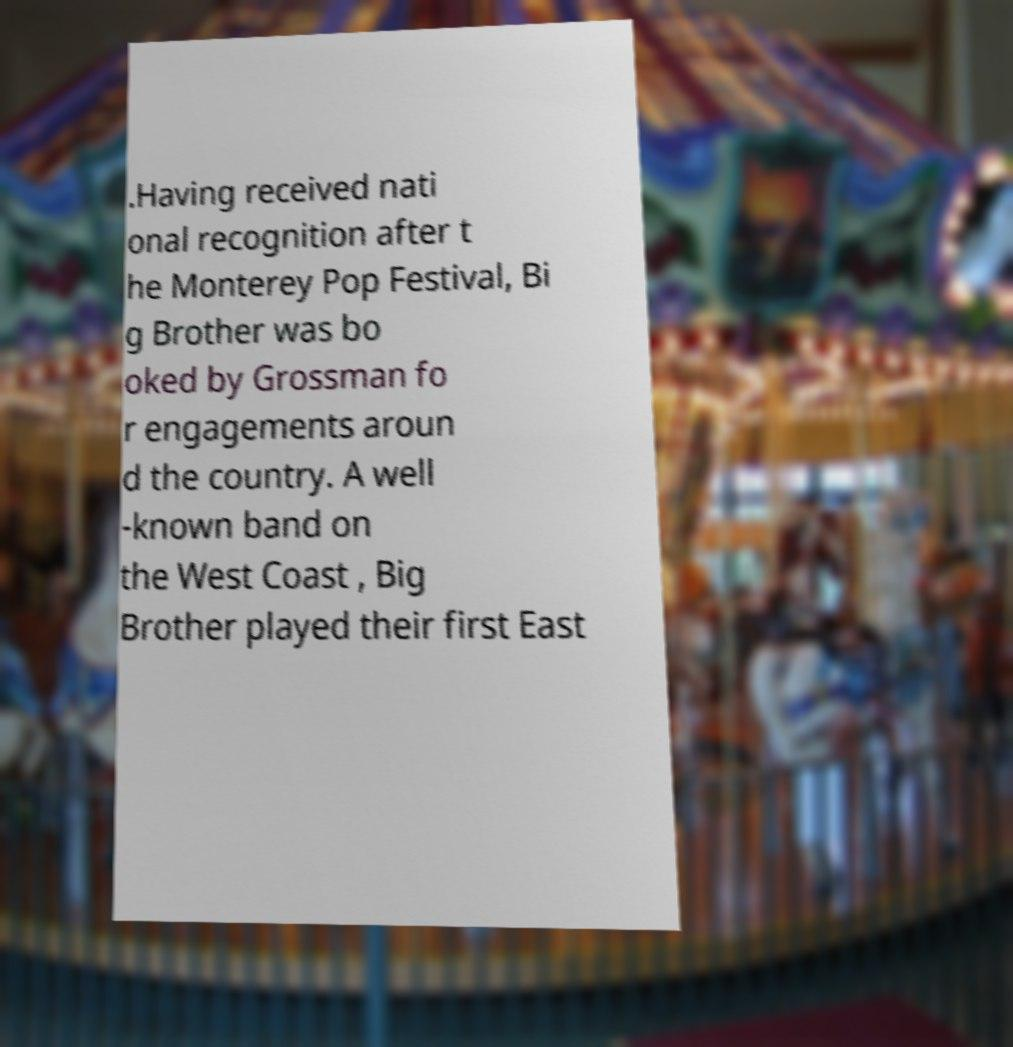Can you read and provide the text displayed in the image?This photo seems to have some interesting text. Can you extract and type it out for me? .Having received nati onal recognition after t he Monterey Pop Festival, Bi g Brother was bo oked by Grossman fo r engagements aroun d the country. A well -known band on the West Coast , Big Brother played their first East 